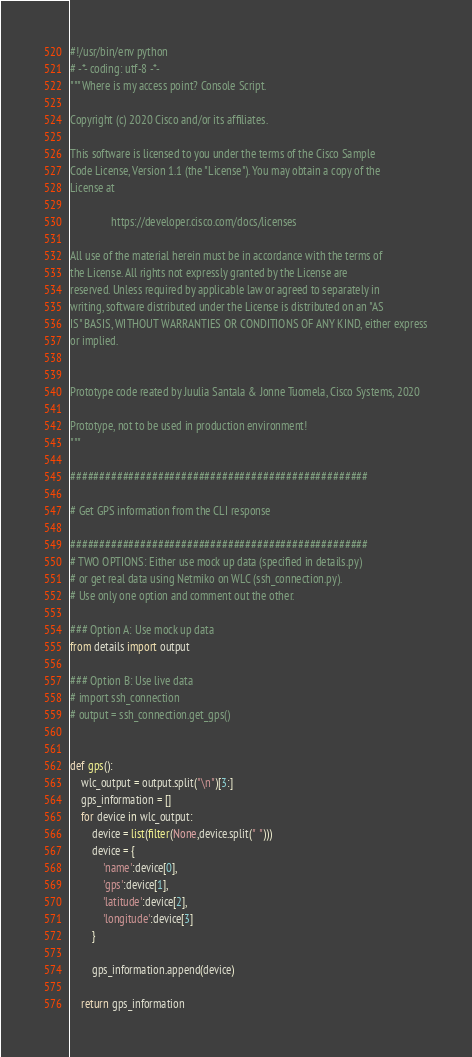Convert code to text. <code><loc_0><loc_0><loc_500><loc_500><_Python_>#!/usr/bin/env python
# -*- coding: utf-8 -*-
"""Where is my access point? Console Script.

Copyright (c) 2020 Cisco and/or its affiliates.

This software is licensed to you under the terms of the Cisco Sample
Code License, Version 1.1 (the "License"). You may obtain a copy of the
License at

               https://developer.cisco.com/docs/licenses

All use of the material herein must be in accordance with the terms of
the License. All rights not expressly granted by the License are
reserved. Unless required by applicable law or agreed to separately in
writing, software distributed under the License is distributed on an "AS
IS" BASIS, WITHOUT WARRANTIES OR CONDITIONS OF ANY KIND, either express
or implied.


Prototype code reated by Juulia Santala & Jonne Tuomela, Cisco Systems, 2020

Prototype, not to be used in production environment!
"""

###################################################

# Get GPS information from the CLI response

###################################################
# TWO OPTIONS: Either use mock up data (specified in details.py)
# or get real data using Netmiko on WLC (ssh_connection.py).
# Use only one option and comment out the other.

### Option A: Use mock up data
from details import output

### Option B: Use live data
# import ssh_connection
# output = ssh_connection.get_gps()


def gps():
	wlc_output = output.split("\n")[3:]
	gps_information = []
	for device in wlc_output:
		device = list(filter(None,device.split(" ")))
		device = {
			'name':device[0],
			'gps':device[1],
			'latitude':device[2],
			'longitude':device[3]
		}

		gps_information.append(device)

	return gps_information</code> 